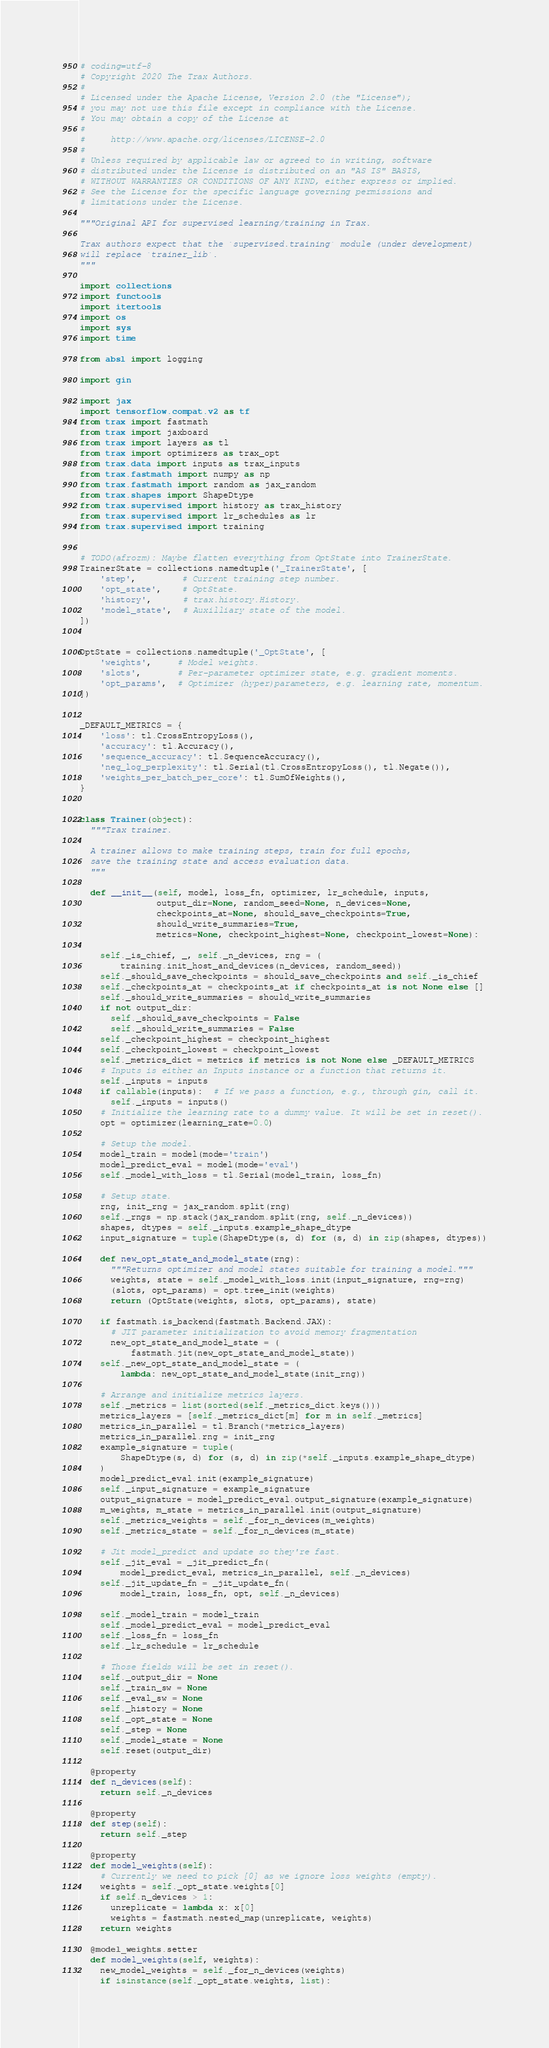Convert code to text. <code><loc_0><loc_0><loc_500><loc_500><_Python_># coding=utf-8
# Copyright 2020 The Trax Authors.
#
# Licensed under the Apache License, Version 2.0 (the "License");
# you may not use this file except in compliance with the License.
# You may obtain a copy of the License at
#
#     http://www.apache.org/licenses/LICENSE-2.0
#
# Unless required by applicable law or agreed to in writing, software
# distributed under the License is distributed on an "AS IS" BASIS,
# WITHOUT WARRANTIES OR CONDITIONS OF ANY KIND, either express or implied.
# See the License for the specific language governing permissions and
# limitations under the License.

"""Original API for supervised learning/training in Trax.

Trax authors expect that the `supervised.training` module (under development)
will replace `trainer_lib`.
"""

import collections
import functools
import itertools
import os
import sys
import time

from absl import logging

import gin

import jax
import tensorflow.compat.v2 as tf
from trax import fastmath
from trax import jaxboard
from trax import layers as tl
from trax import optimizers as trax_opt
from trax.data import inputs as trax_inputs
from trax.fastmath import numpy as np
from trax.fastmath import random as jax_random
from trax.shapes import ShapeDtype
from trax.supervised import history as trax_history
from trax.supervised import lr_schedules as lr
from trax.supervised import training


# TODO(afrozm): Maybe flatten everything from OptState into TrainerState.
TrainerState = collections.namedtuple('_TrainerState', [
    'step',         # Current training step number.
    'opt_state',    # OptState.
    'history',      # trax.history.History.
    'model_state',  # Auxilliary state of the model.
])


OptState = collections.namedtuple('_OptState', [
    'weights',     # Model weights.
    'slots',       # Per-parameter optimizer state, e.g. gradient moments.
    'opt_params',  # Optimizer (hyper)parameters, e.g. learning rate, momentum.
])


_DEFAULT_METRICS = {
    'loss': tl.CrossEntropyLoss(),
    'accuracy': tl.Accuracy(),
    'sequence_accuracy': tl.SequenceAccuracy(),
    'neg_log_perplexity': tl.Serial(tl.CrossEntropyLoss(), tl.Negate()),
    'weights_per_batch_per_core': tl.SumOfWeights(),
}


class Trainer(object):
  """Trax trainer.

  A trainer allows to make training steps, train for full epochs,
  save the training state and access evaluation data.
  """

  def __init__(self, model, loss_fn, optimizer, lr_schedule, inputs,
               output_dir=None, random_seed=None, n_devices=None,
               checkpoints_at=None, should_save_checkpoints=True,
               should_write_summaries=True,
               metrics=None, checkpoint_highest=None, checkpoint_lowest=None):

    self._is_chief, _, self._n_devices, rng = (
        training.init_host_and_devices(n_devices, random_seed))
    self._should_save_checkpoints = should_save_checkpoints and self._is_chief
    self._checkpoints_at = checkpoints_at if checkpoints_at is not None else []
    self._should_write_summaries = should_write_summaries
    if not output_dir:
      self._should_save_checkpoints = False
      self._should_write_summaries = False
    self._checkpoint_highest = checkpoint_highest
    self._checkpoint_lowest = checkpoint_lowest
    self._metrics_dict = metrics if metrics is not None else _DEFAULT_METRICS
    # Inputs is either an Inputs instance or a function that returns it.
    self._inputs = inputs
    if callable(inputs):  # If we pass a function, e.g., through gin, call it.
      self._inputs = inputs()
    # Initialize the learning rate to a dummy value. It will be set in reset().
    opt = optimizer(learning_rate=0.0)

    # Setup the model.
    model_train = model(mode='train')
    model_predict_eval = model(mode='eval')
    self._model_with_loss = tl.Serial(model_train, loss_fn)

    # Setup state.
    rng, init_rng = jax_random.split(rng)
    self._rngs = np.stack(jax_random.split(rng, self._n_devices))
    shapes, dtypes = self._inputs.example_shape_dtype
    input_signature = tuple(ShapeDtype(s, d) for (s, d) in zip(shapes, dtypes))

    def new_opt_state_and_model_state(rng):
      """Returns optimizer and model states suitable for training a model."""
      weights, state = self._model_with_loss.init(input_signature, rng=rng)
      (slots, opt_params) = opt.tree_init(weights)
      return (OptState(weights, slots, opt_params), state)

    if fastmath.is_backend(fastmath.Backend.JAX):
      # JIT parameter initialization to avoid memory fragmentation
      new_opt_state_and_model_state = (
          fastmath.jit(new_opt_state_and_model_state))
    self._new_opt_state_and_model_state = (
        lambda: new_opt_state_and_model_state(init_rng))

    # Arrange and initialize metrics layers.
    self._metrics = list(sorted(self._metrics_dict.keys()))
    metrics_layers = [self._metrics_dict[m] for m in self._metrics]
    metrics_in_parallel = tl.Branch(*metrics_layers)
    metrics_in_parallel.rng = init_rng
    example_signature = tuple(
        ShapeDtype(s, d) for (s, d) in zip(*self._inputs.example_shape_dtype)
    )
    model_predict_eval.init(example_signature)
    self._input_signature = example_signature
    output_signature = model_predict_eval.output_signature(example_signature)
    m_weights, m_state = metrics_in_parallel.init(output_signature)
    self._metrics_weights = self._for_n_devices(m_weights)
    self._metrics_state = self._for_n_devices(m_state)

    # Jit model_predict and update so they're fast.
    self._jit_eval = _jit_predict_fn(
        model_predict_eval, metrics_in_parallel, self._n_devices)
    self._jit_update_fn = _jit_update_fn(
        model_train, loss_fn, opt, self._n_devices)

    self._model_train = model_train
    self._model_predict_eval = model_predict_eval
    self._loss_fn = loss_fn
    self._lr_schedule = lr_schedule

    # Those fields will be set in reset().
    self._output_dir = None
    self._train_sw = None
    self._eval_sw = None
    self._history = None
    self._opt_state = None
    self._step = None
    self._model_state = None
    self.reset(output_dir)

  @property
  def n_devices(self):
    return self._n_devices

  @property
  def step(self):
    return self._step

  @property
  def model_weights(self):
    # Currently we need to pick [0] as we ignore loss weights (empty).
    weights = self._opt_state.weights[0]
    if self.n_devices > 1:
      unreplicate = lambda x: x[0]
      weights = fastmath.nested_map(unreplicate, weights)
    return weights

  @model_weights.setter
  def model_weights(self, weights):
    new_model_weights = self._for_n_devices(weights)
    if isinstance(self._opt_state.weights, list):</code> 